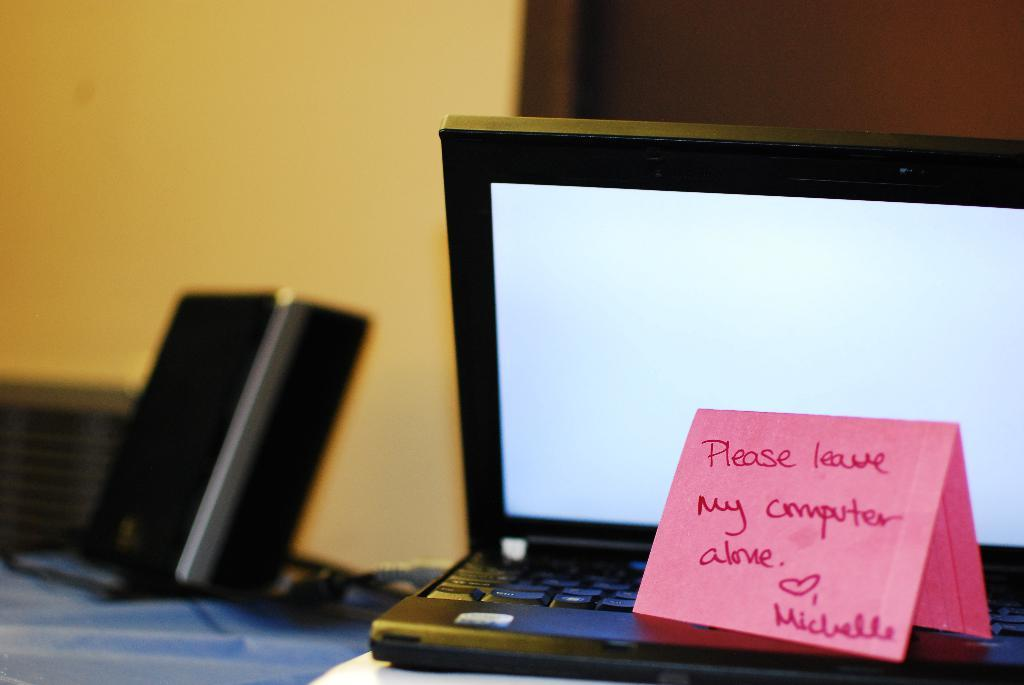Provide a one-sentence caption for the provided image. Laptop with a note on it that says "Please leave my computer alone". 